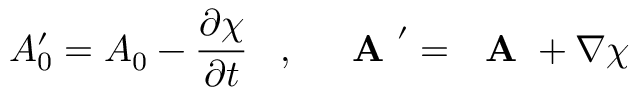<formula> <loc_0><loc_0><loc_500><loc_500>A _ { 0 } ^ { \prime } = A _ { 0 } - \frac { \partial \chi } { \partial t } \, , \, A ^ { \prime } = A + \nabla \chi</formula> 